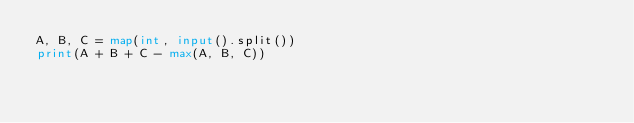Convert code to text. <code><loc_0><loc_0><loc_500><loc_500><_Python_>A, B, C = map(int, input().split())
print(A + B + C - max(A, B, C))</code> 